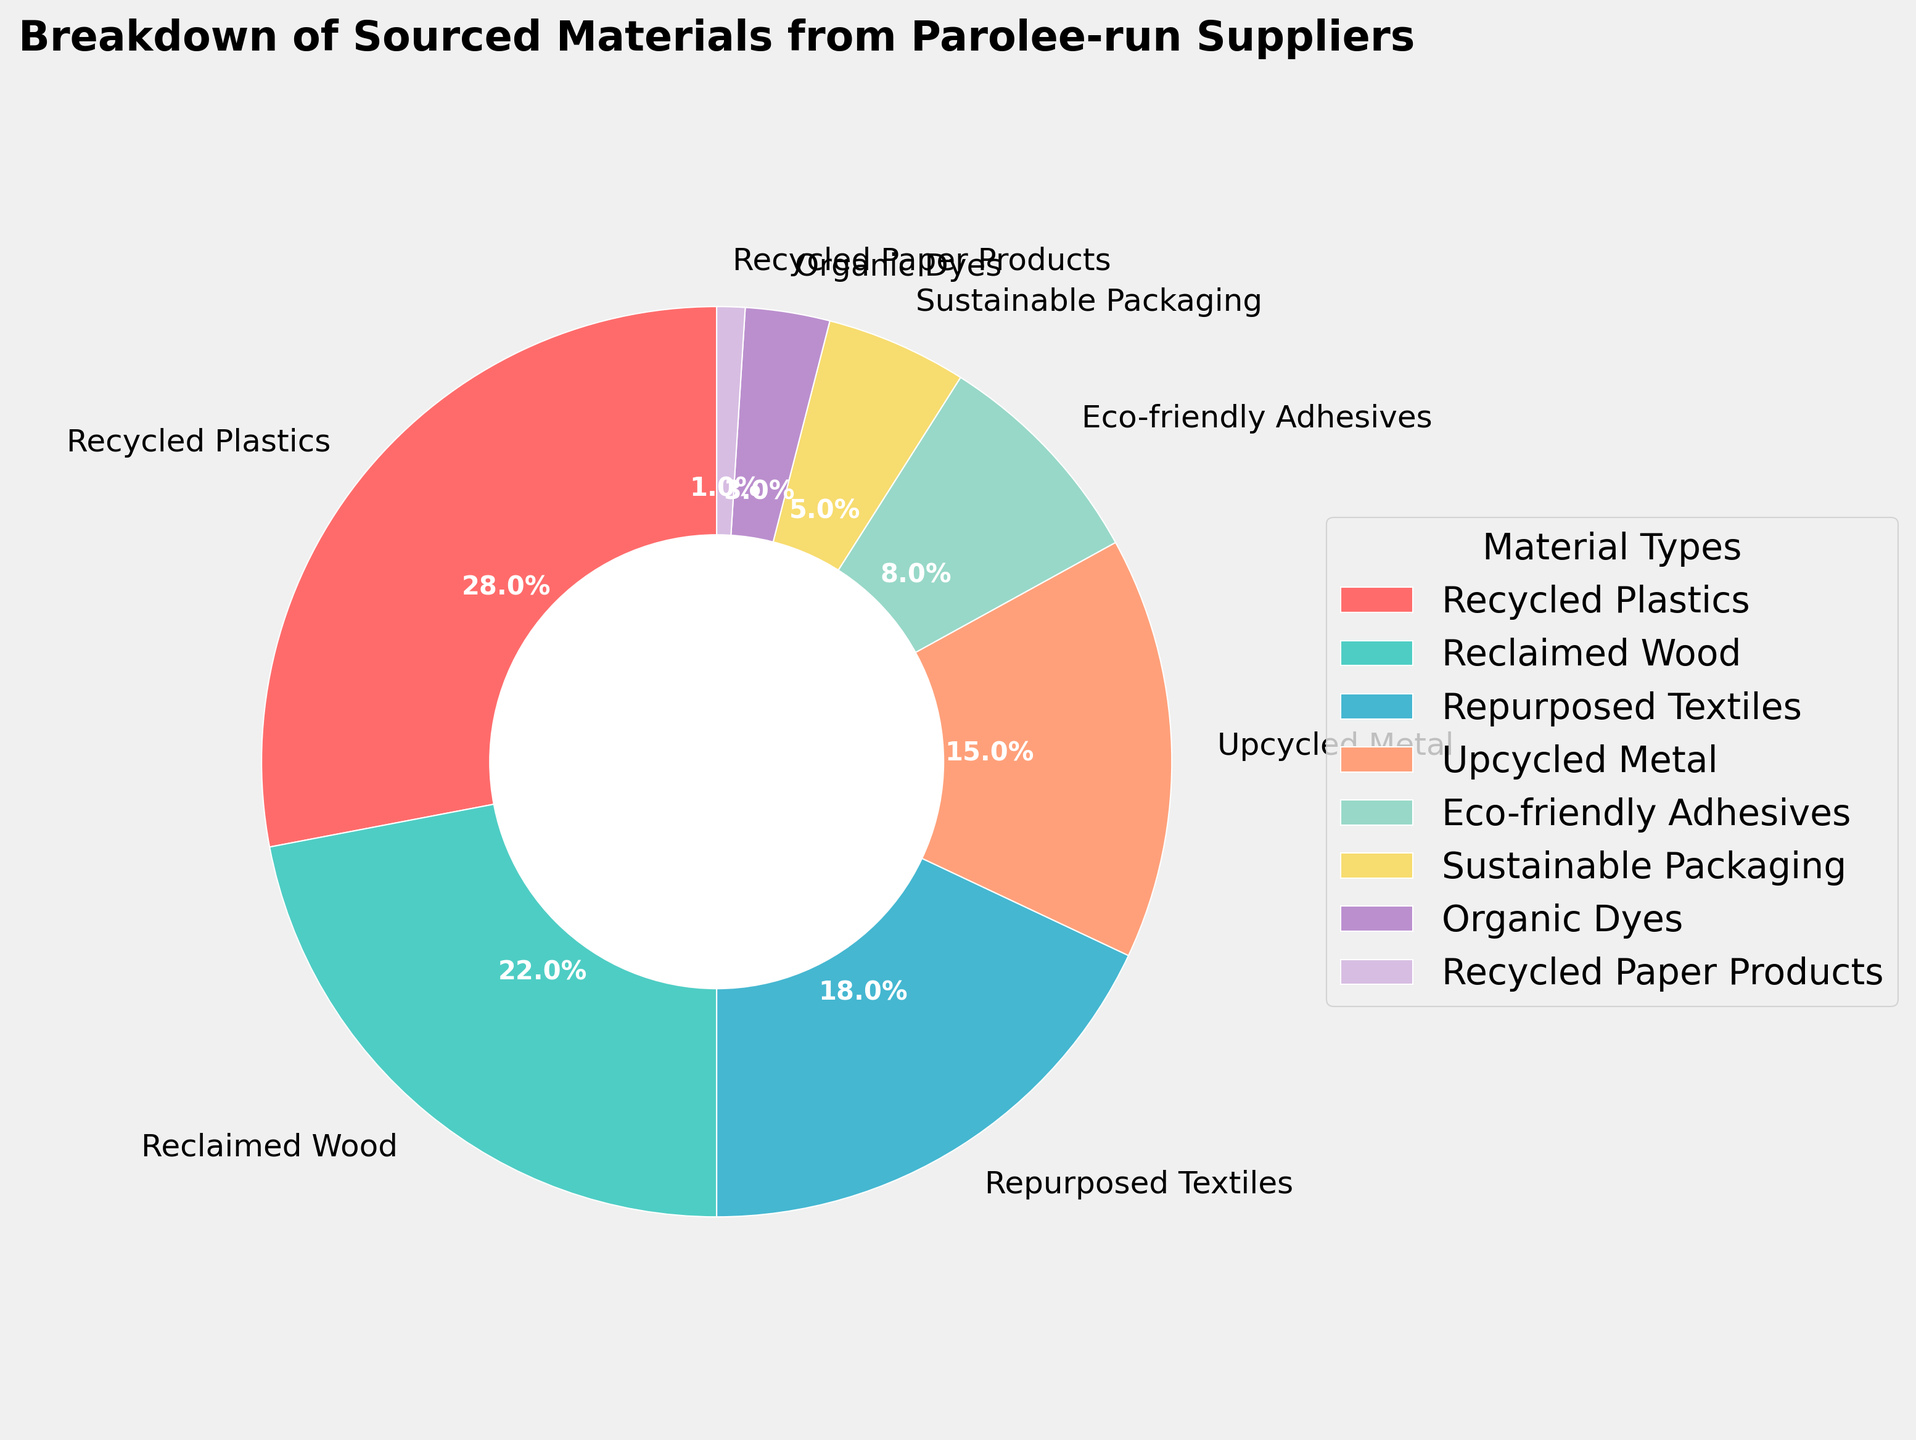What percentage of sourced materials is made up of Recycled Plastics and Reclaimed Wood combined? The percentage for Recycled Plastics is 28% and for Reclaimed Wood is 22%. Combining these gives 28% + 22% = 50%.
Answer: 50% Which material type has the smallest percentage? The smallest segment of the pie chart corresponds to Recycled Paper Products, which occupies 1%.
Answer: Recycled Paper Products How many material types have a percentage greater than 20%? The material types Recycled Plastics (28%) and Reclaimed Wood (22%) both have percentages greater than 20%. Therefore, there are 2 material types.
Answer: 2 Is the percentage of Repurposed Textiles greater than that of Upcycled Metal? The percentage of Repurposed Textiles is 18% and that of Upcycled Metal is 15%. Since 18% is greater, Repurposed Textiles have a greater percentage than Upcycled Metal.
Answer: Yes What is the combined percentage of the three smallest segments? The three smallest segments are Recycled Paper Products (1%), Organic Dyes (3%), and Sustainable Packaging (5%). Adding these gives 1% + 3% + 5% = 9%.
Answer: 9% Which segment has the second largest share in the pie chart? The segment with the second largest percentage is Reclaimed Wood with 22%, following Recycled Plastics which is 28%.
Answer: Reclaimed Wood What is the difference in percentage between Upcycled Metal and Eco-friendly Adhesives? Upcycled Metal has a percentage of 15% and Eco-friendly Adhesives have 8%. The difference is 15% - 8% = 7%.
Answer: 7% Is the share of Recycled Plastics more than double that of Repurposed Textiles? Recycled Plastics are 28% and Repurposed Textiles are 18%. Doubling 18% gives 36% which is greater than 28%, so the share of Recycled Plastics is not more than double that of Repurposed Textiles.
Answer: No Which two segments have a combined percentage equal to the percentage of Repurposed Textiles? Reclaimed Wood (22%) and Sustainable Packaging (5%) combined give 22% + 5% = 27%, which is not equal. Considering different combinations further, Upcycled Metal (15%) and Eco-friendly Adhesives (8%) combined give 15% + 8% = 23%, still not equal. Combining Eco-friendly Adhesives (8%) and Sustainable Packaging (5%) gives 8% + 5% = 13%, still not equal. Thus, none of the combinations equal 18% directly.
Answer: None 